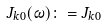<formula> <loc_0><loc_0><loc_500><loc_500>J _ { k 0 } ( \omega ) \colon = J _ { k 0 }</formula> 